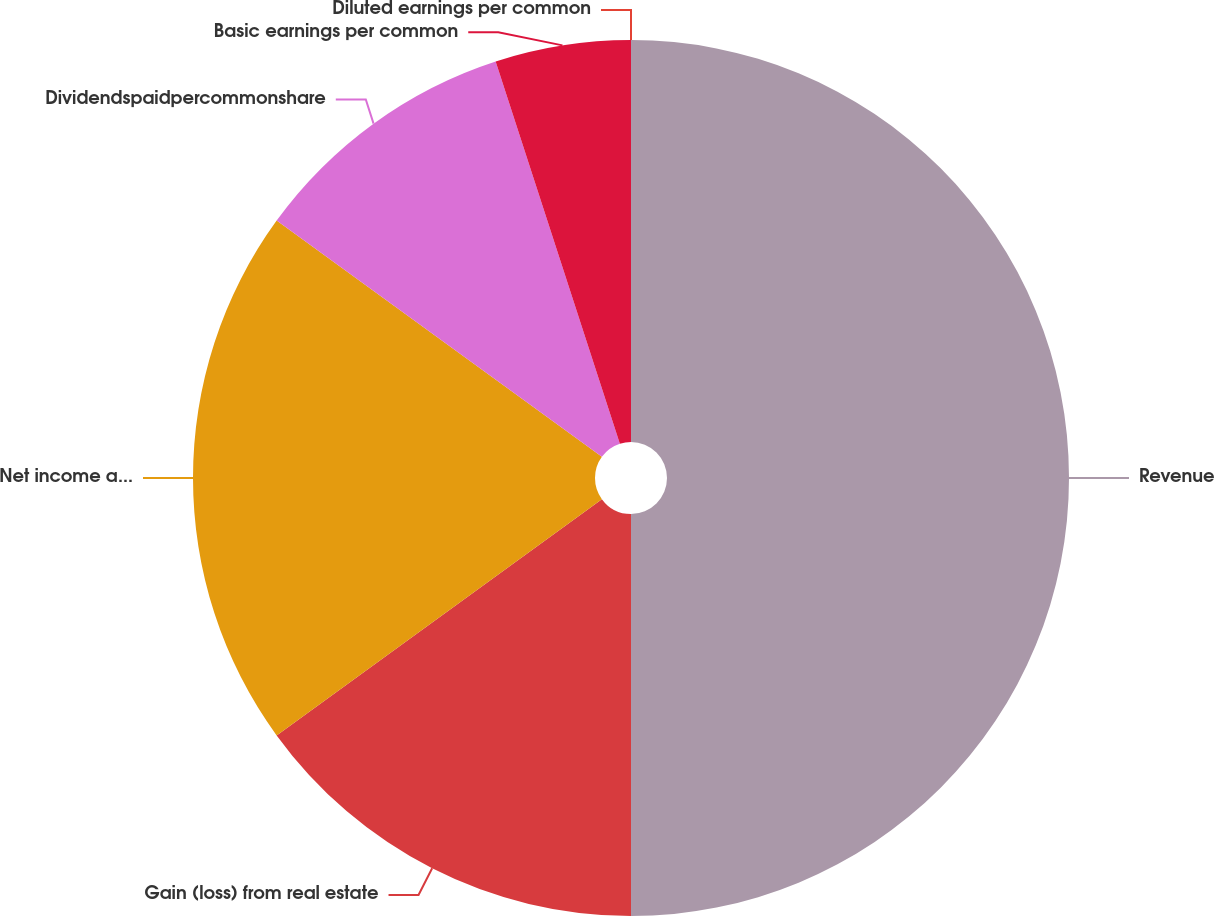Convert chart to OTSL. <chart><loc_0><loc_0><loc_500><loc_500><pie_chart><fcel>Revenue<fcel>Gain (loss) from real estate<fcel>Net income applicable to<fcel>Dividendspaidpercommonshare<fcel>Basic earnings per common<fcel>Diluted earnings per common<nl><fcel>50.0%<fcel>15.0%<fcel>20.0%<fcel>10.0%<fcel>5.0%<fcel>0.0%<nl></chart> 